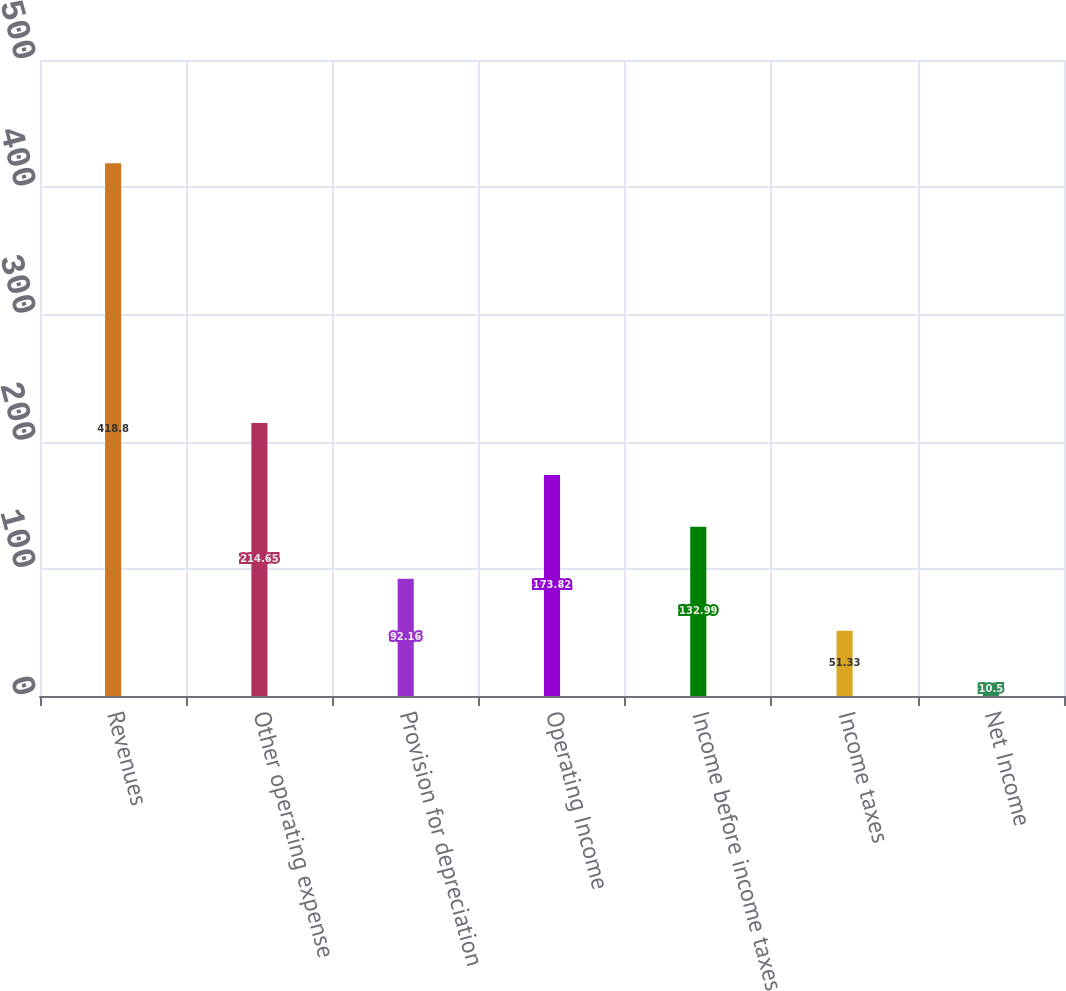Convert chart. <chart><loc_0><loc_0><loc_500><loc_500><bar_chart><fcel>Revenues<fcel>Other operating expense<fcel>Provision for depreciation<fcel>Operating Income<fcel>Income before income taxes<fcel>Income taxes<fcel>Net Income<nl><fcel>418.8<fcel>214.65<fcel>92.16<fcel>173.82<fcel>132.99<fcel>51.33<fcel>10.5<nl></chart> 